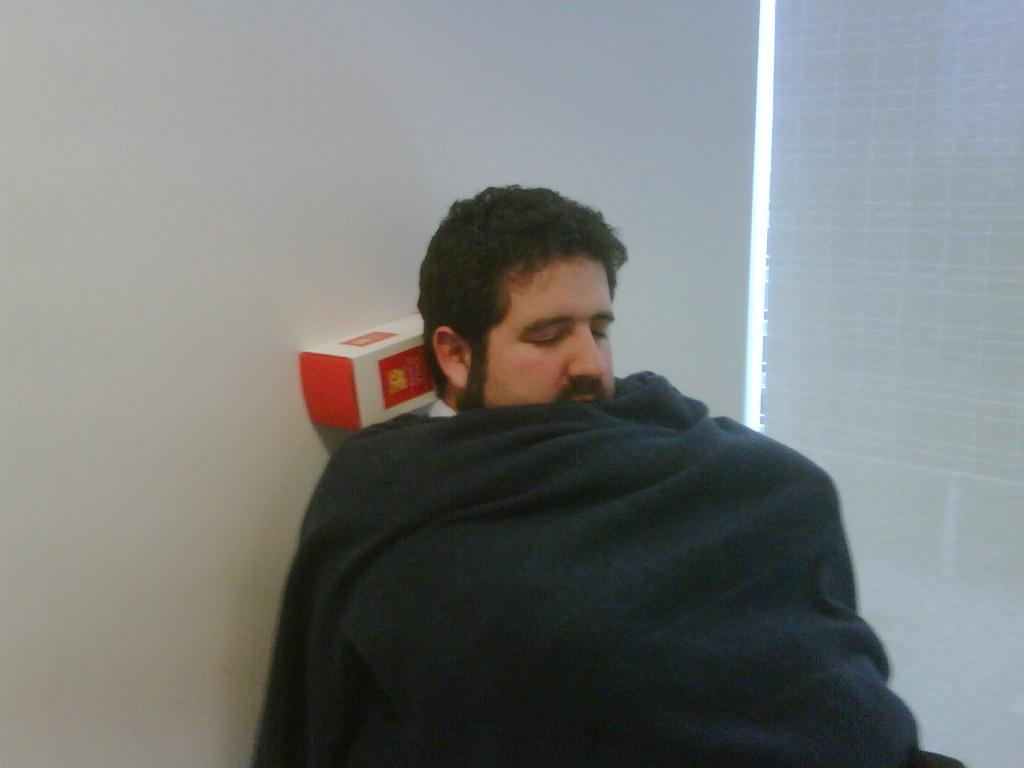What is the person in the image doing? The person is sleeping in the image. How is the person covered while sleeping? The person is covered by a blanket. What objects can be seen in the image besides the sleeping person? There are boxes in the image. What can be seen in the background of the image? There is a wall and a window in the background of the image. Are there any window treatments visible in the image? Yes, there are blinds associated with the window. What does the partner of the person in the image believe about the current situation? There is no partner present in the image, so it is not possible to determine what they might believe about the current situation. 